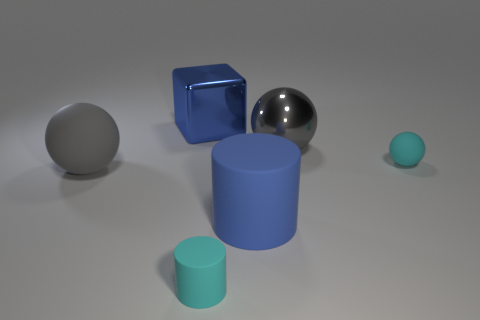Add 2 cyan rubber objects. How many objects exist? 8 Subtract all cubes. How many objects are left? 5 Add 6 matte balls. How many matte balls are left? 8 Add 6 tiny cylinders. How many tiny cylinders exist? 7 Subtract 0 brown spheres. How many objects are left? 6 Subtract all cylinders. Subtract all gray metallic spheres. How many objects are left? 3 